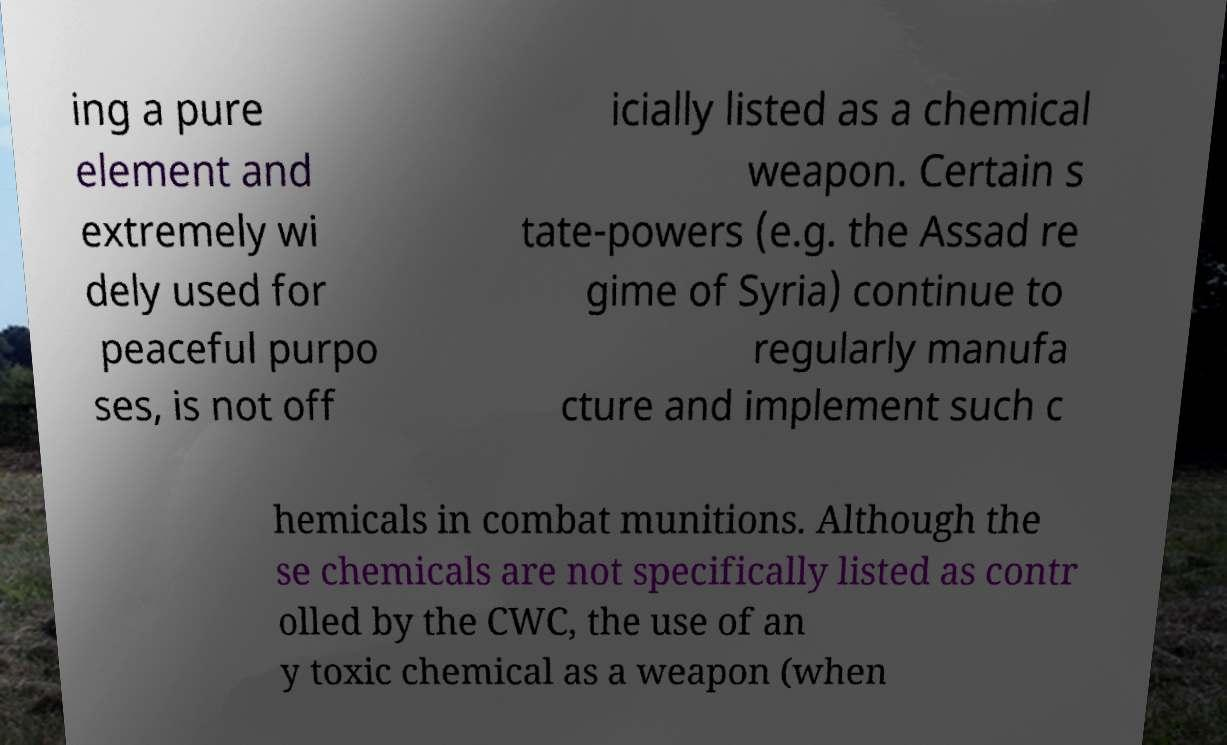Can you accurately transcribe the text from the provided image for me? ing a pure element and extremely wi dely used for peaceful purpo ses, is not off icially listed as a chemical weapon. Certain s tate-powers (e.g. the Assad re gime of Syria) continue to regularly manufa cture and implement such c hemicals in combat munitions. Although the se chemicals are not specifically listed as contr olled by the CWC, the use of an y toxic chemical as a weapon (when 